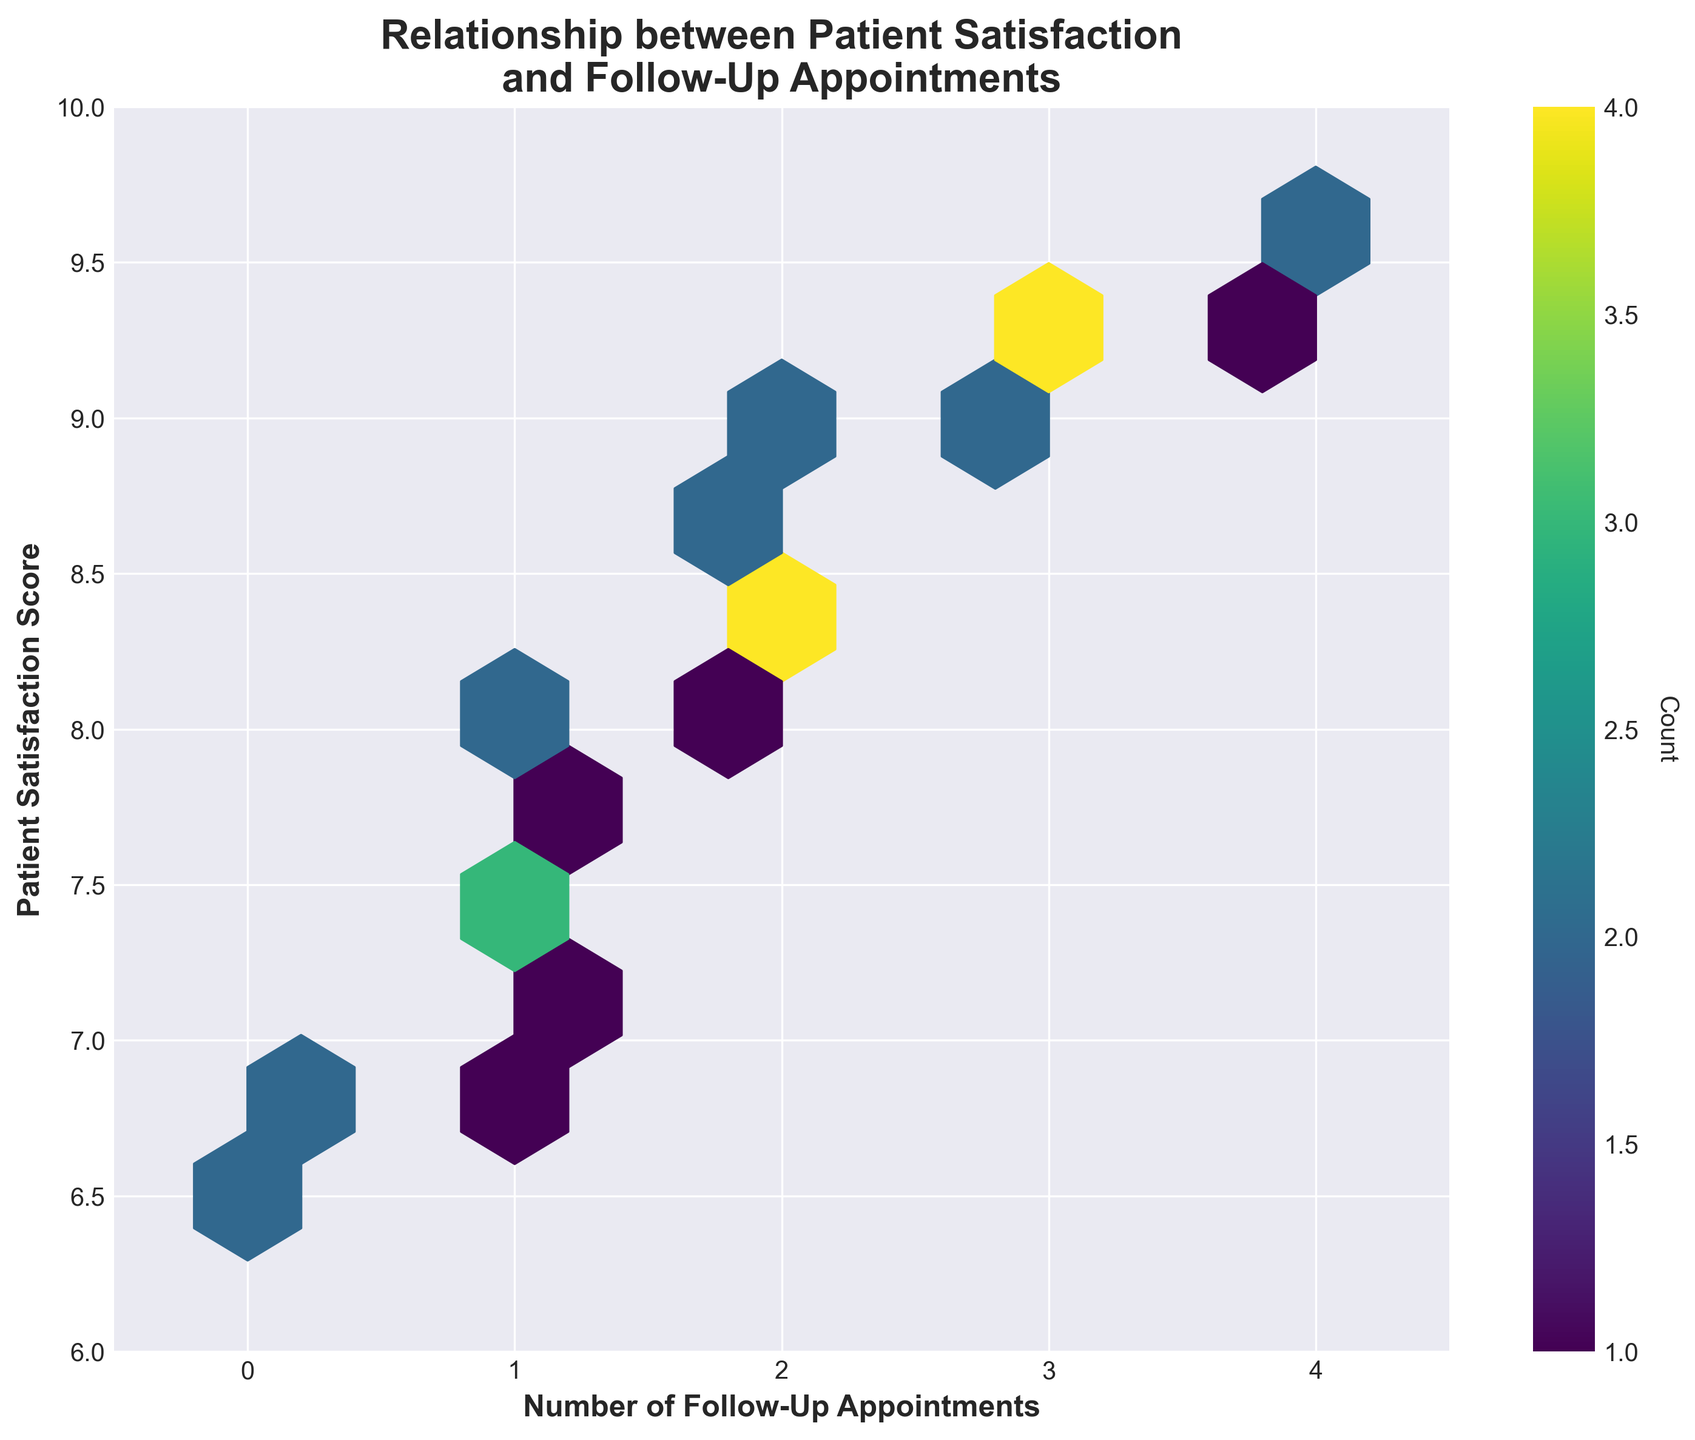What is the title of the plot? The title is usually at the top of the plot, giving a brief summary of what is being depicted.
Answer: Relationship between Patient Satisfaction and Follow-Up Appointments How many axes does the plot have? Plots typically have two axes: the x-axis (horizontal) and the y-axis (vertical).
Answer: Two What is the range of the y-axis in the plot? The range of the y-axis is determined by observing the smallest and largest values it covers. In this case, it runs from 6 to 10.
Answer: 6 to 10 What is the range of the x-axis in the plot? The range of the x-axis can be observed from the minimum to the maximum value it displays. Here, it runs from -0.5 to 4.5.
Answer: -0.5 to 4.5 What color scheme is used for the hexbin plot? The color scheme can be determined by observing the color that the hexagons are shaded with. In this plot, 'viridis' is used.
Answer: Viridis Which color represents the highest concentration of data points in the hexbin plot? Typically, in a hexbin plot, lighter or more intense colors indicate higher concentrations of data points.
Answer: Lightest color in Viridis scheme Can we see more patient satisfaction scores with 2 follow-up appointments or 4 follow-up appointments? By observing the concentration of hexagons at specific follow-up appointment intervals, you can see which has more data points.
Answer: 2 follow-up appointments Which follow-up appointment count shows the least patient satisfaction scores in the plot? By looking at the hexagons along each follow-up appointment interval, you can observe which interval has the fewest or no hexagons.
Answer: 0 follow-up appointments How many follow-up appointments correspond to the highest patient satisfaction score (around 9.6)? Observe the horizontal position (x-axis) corresponding to the vertical value (y-axis) of around 9.6.
Answer: 4 Is there any indication of a trend in the relationship between the number of follow-up appointments and patient satisfaction score? By visually inspecting the hexbin plot, you can discern a general trend or pattern between the two variables. Here, an increasing number of follow-up appointments tend to align with higher satisfaction scores.
Answer: More follow-up appointments seem to correspond to higher satisfaction scores 